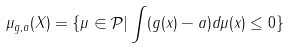<formula> <loc_0><loc_0><loc_500><loc_500>\mu _ { g , a } ( X ) = \{ \mu \in \mathcal { P } | \int ( g ( x ) - a ) d \mu ( x ) \leq 0 \}</formula> 